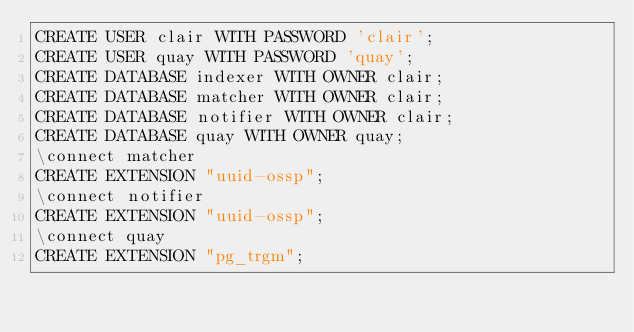Convert code to text. <code><loc_0><loc_0><loc_500><loc_500><_SQL_>CREATE USER clair WITH PASSWORD 'clair';
CREATE USER quay WITH PASSWORD 'quay';
CREATE DATABASE indexer WITH OWNER clair;
CREATE DATABASE matcher WITH OWNER clair;
CREATE DATABASE notifier WITH OWNER clair;
CREATE DATABASE quay WITH OWNER quay;
\connect matcher
CREATE EXTENSION "uuid-ossp";
\connect notifier
CREATE EXTENSION "uuid-ossp";
\connect quay
CREATE EXTENSION "pg_trgm";
</code> 